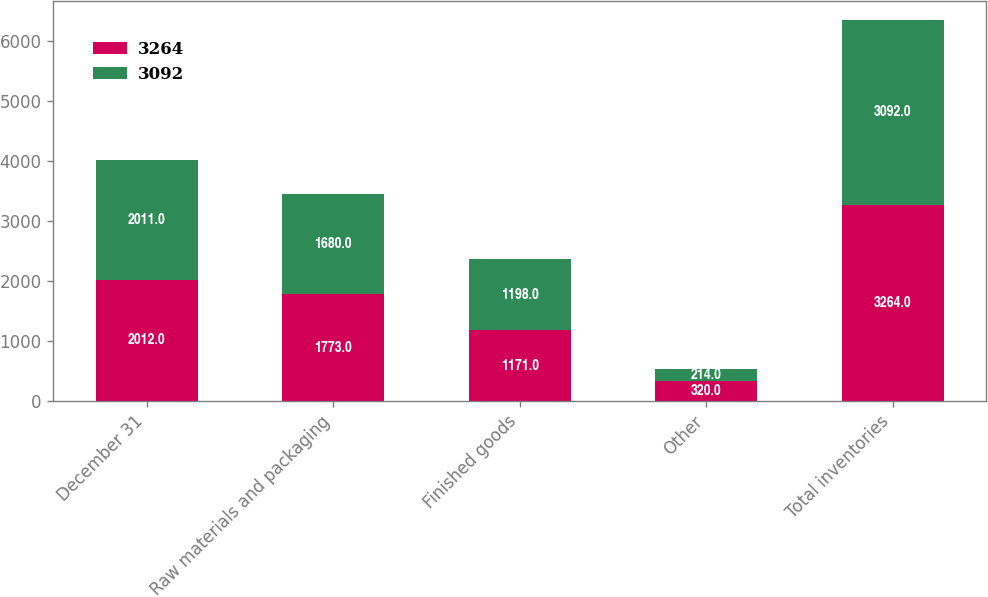Convert chart to OTSL. <chart><loc_0><loc_0><loc_500><loc_500><stacked_bar_chart><ecel><fcel>December 31<fcel>Raw materials and packaging<fcel>Finished goods<fcel>Other<fcel>Total inventories<nl><fcel>3264<fcel>2012<fcel>1773<fcel>1171<fcel>320<fcel>3264<nl><fcel>3092<fcel>2011<fcel>1680<fcel>1198<fcel>214<fcel>3092<nl></chart> 